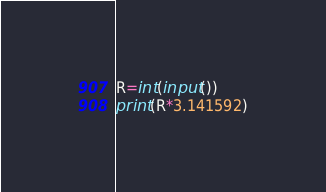<code> <loc_0><loc_0><loc_500><loc_500><_Python_>R=int(input())
print(R*3.141592)</code> 